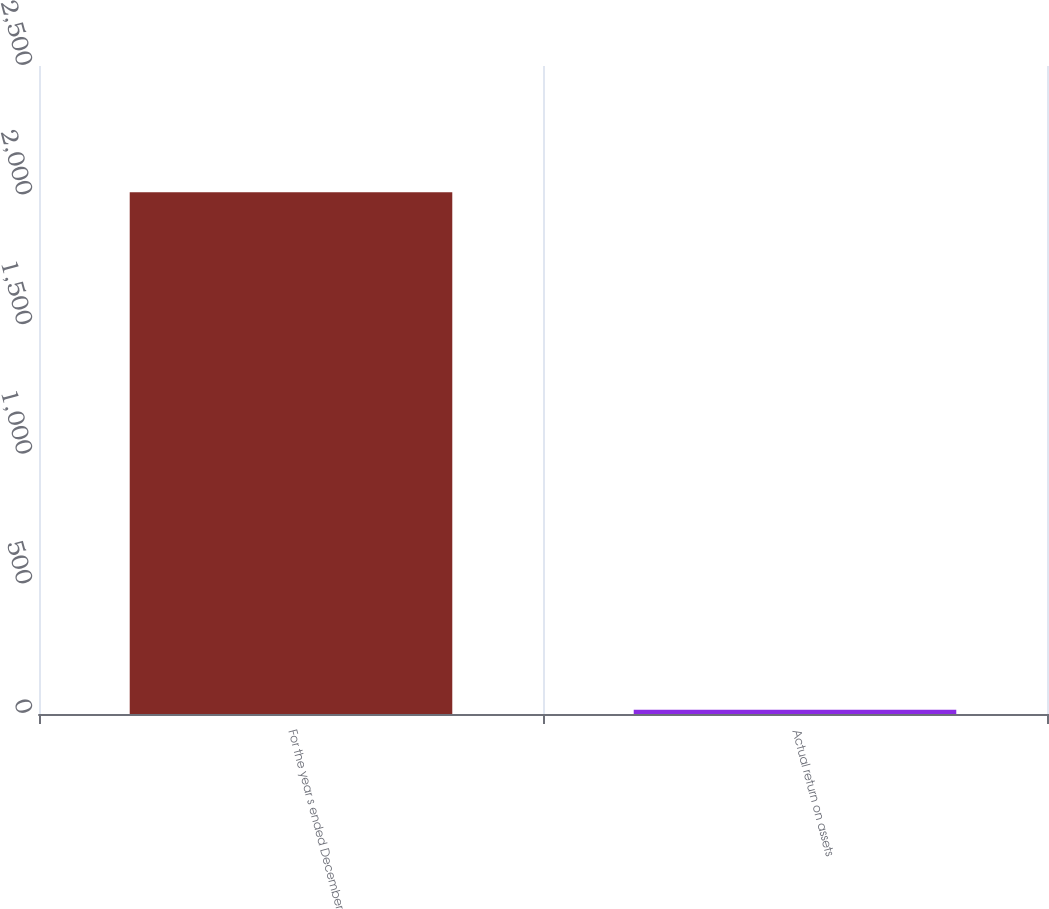Convert chart to OTSL. <chart><loc_0><loc_0><loc_500><loc_500><bar_chart><fcel>For the year s ended December<fcel>Actual return on assets<nl><fcel>2013<fcel>16.7<nl></chart> 